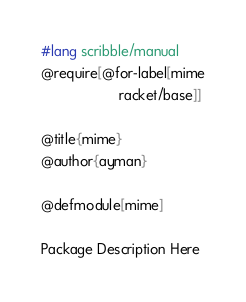<code> <loc_0><loc_0><loc_500><loc_500><_Racket_>#lang scribble/manual
@require[@for-label[mime
                    racket/base]]

@title{mime}
@author{ayman}

@defmodule[mime]

Package Description Here
</code> 